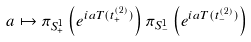Convert formula to latex. <formula><loc_0><loc_0><loc_500><loc_500>a \mapsto \pi _ { S ^ { 1 } _ { + } } \left ( e ^ { i a T ( t ^ { ( 2 ) } _ { + } ) } \right ) \pi _ { S ^ { 1 } _ { - } } \left ( e ^ { i a T ( t ^ { ( 2 ) } _ { - } ) } \right )</formula> 